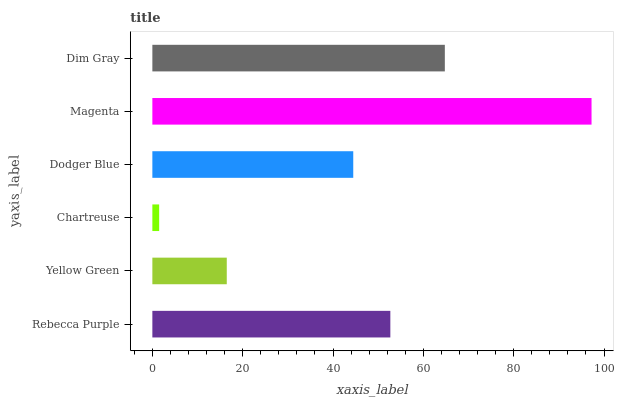Is Chartreuse the minimum?
Answer yes or no. Yes. Is Magenta the maximum?
Answer yes or no. Yes. Is Yellow Green the minimum?
Answer yes or no. No. Is Yellow Green the maximum?
Answer yes or no. No. Is Rebecca Purple greater than Yellow Green?
Answer yes or no. Yes. Is Yellow Green less than Rebecca Purple?
Answer yes or no. Yes. Is Yellow Green greater than Rebecca Purple?
Answer yes or no. No. Is Rebecca Purple less than Yellow Green?
Answer yes or no. No. Is Rebecca Purple the high median?
Answer yes or no. Yes. Is Dodger Blue the low median?
Answer yes or no. Yes. Is Magenta the high median?
Answer yes or no. No. Is Chartreuse the low median?
Answer yes or no. No. 